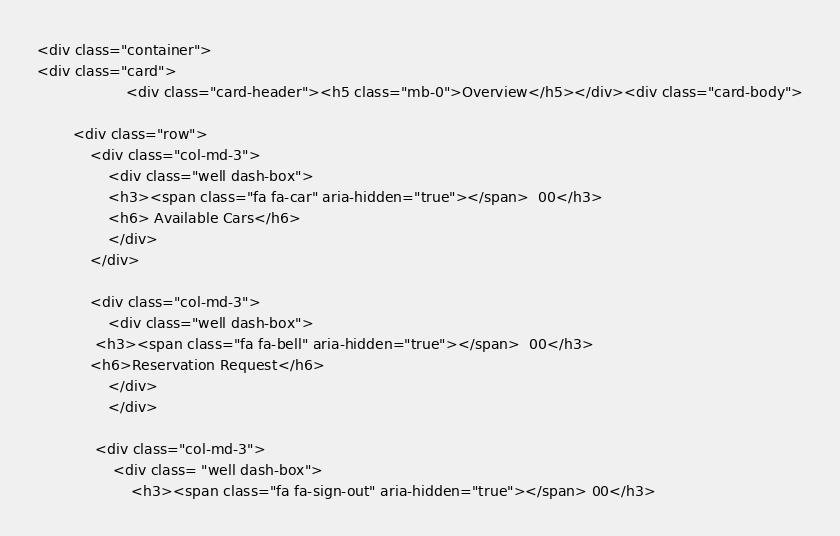Convert code to text. <code><loc_0><loc_0><loc_500><loc_500><_PHP_><div class="container">
<div class="card">
                    <div class="card-header"><h5 class="mb-0">Overview</h5></div><div class="card-body">
    
        <div class="row">
            <div class="col-md-3">
                <div class="well dash-box">
                <h3><span class="fa fa-car" aria-hidden="true"></span>  00</h3>
                <h6> Available Cars</h6>
                </div>
            </div>
           
            <div class="col-md-3">
                <div class="well dash-box">
             <h3><span class="fa fa-bell" aria-hidden="true"></span>  00</h3>
            <h6>Reservation Request</h6>
                </div>
                </div>
           
             <div class="col-md-3">
                 <div class= "well dash-box"> 
                     <h3><span class="fa fa-sign-out" aria-hidden="true"></span> 00</h3></code> 